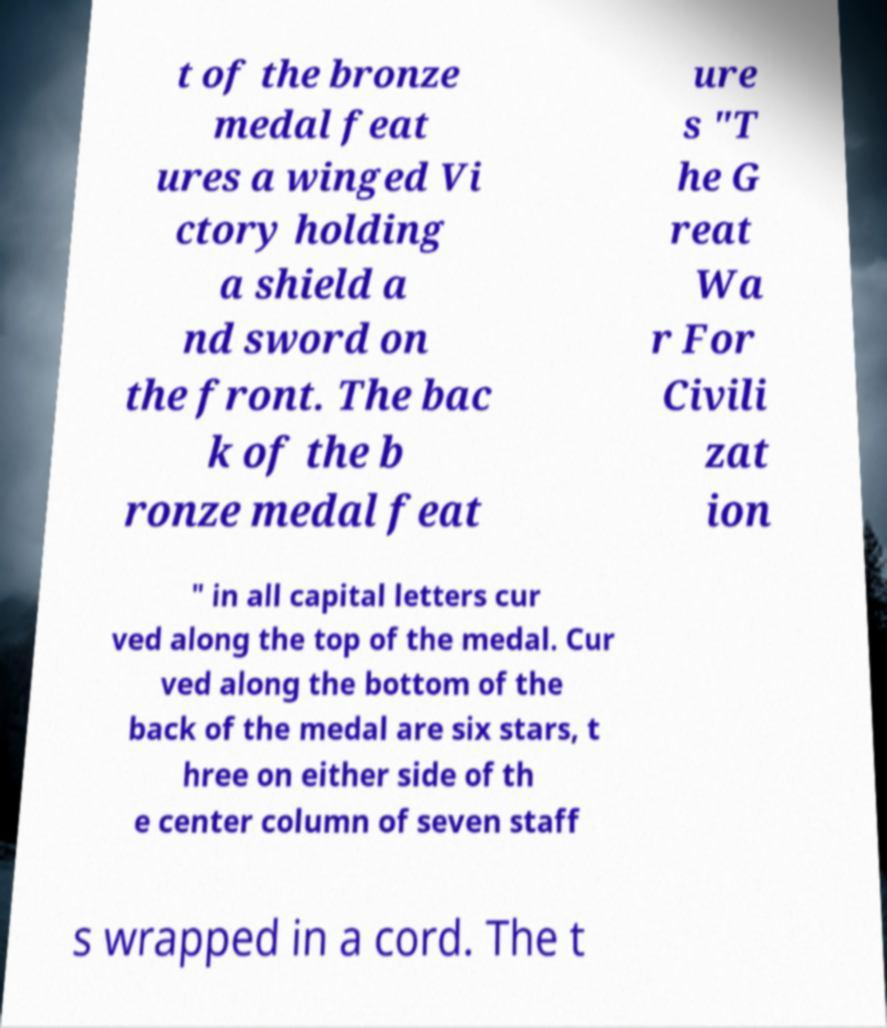Can you accurately transcribe the text from the provided image for me? t of the bronze medal feat ures a winged Vi ctory holding a shield a nd sword on the front. The bac k of the b ronze medal feat ure s "T he G reat Wa r For Civili zat ion " in all capital letters cur ved along the top of the medal. Cur ved along the bottom of the back of the medal are six stars, t hree on either side of th e center column of seven staff s wrapped in a cord. The t 